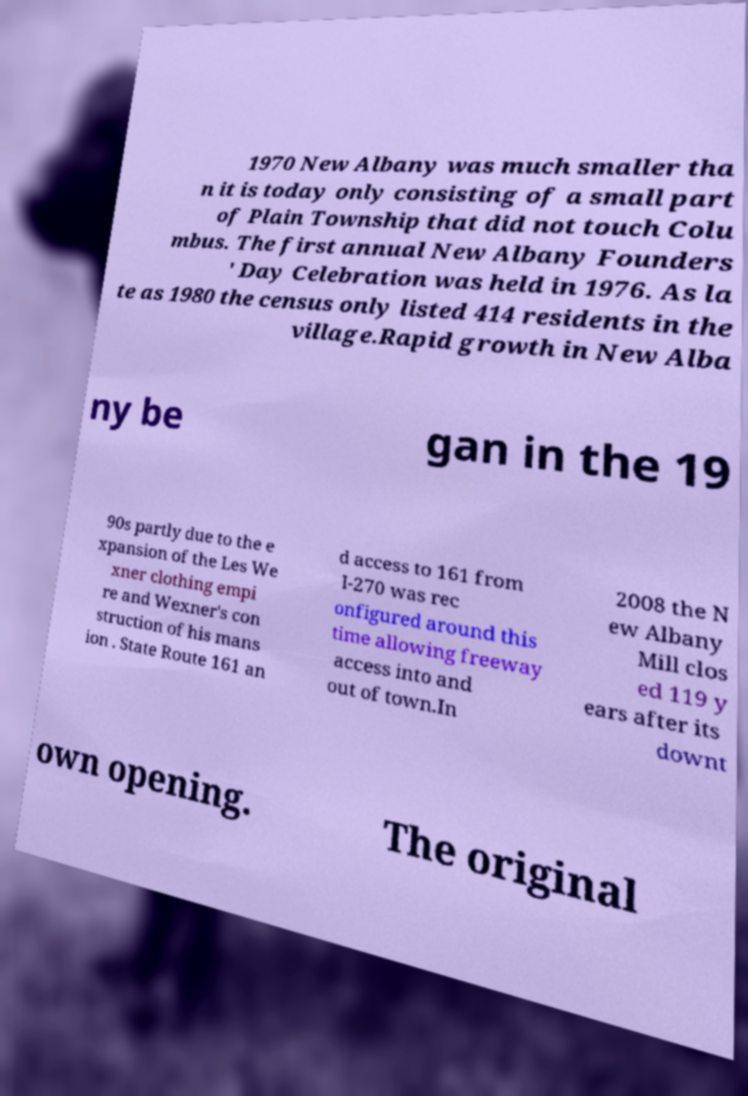Could you extract and type out the text from this image? 1970 New Albany was much smaller tha n it is today only consisting of a small part of Plain Township that did not touch Colu mbus. The first annual New Albany Founders ' Day Celebration was held in 1976. As la te as 1980 the census only listed 414 residents in the village.Rapid growth in New Alba ny be gan in the 19 90s partly due to the e xpansion of the Les We xner clothing empi re and Wexner's con struction of his mans ion . State Route 161 an d access to 161 from I-270 was rec onfigured around this time allowing freeway access into and out of town.In 2008 the N ew Albany Mill clos ed 119 y ears after its downt own opening. The original 